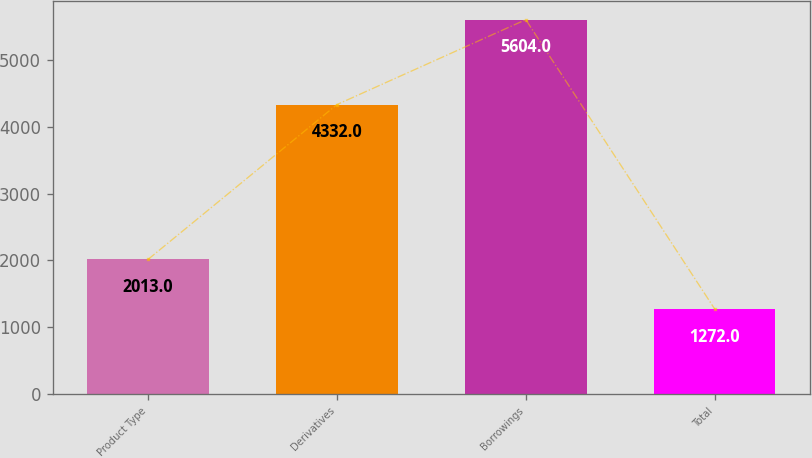<chart> <loc_0><loc_0><loc_500><loc_500><bar_chart><fcel>Product Type<fcel>Derivatives<fcel>Borrowings<fcel>Total<nl><fcel>2013<fcel>4332<fcel>5604<fcel>1272<nl></chart> 